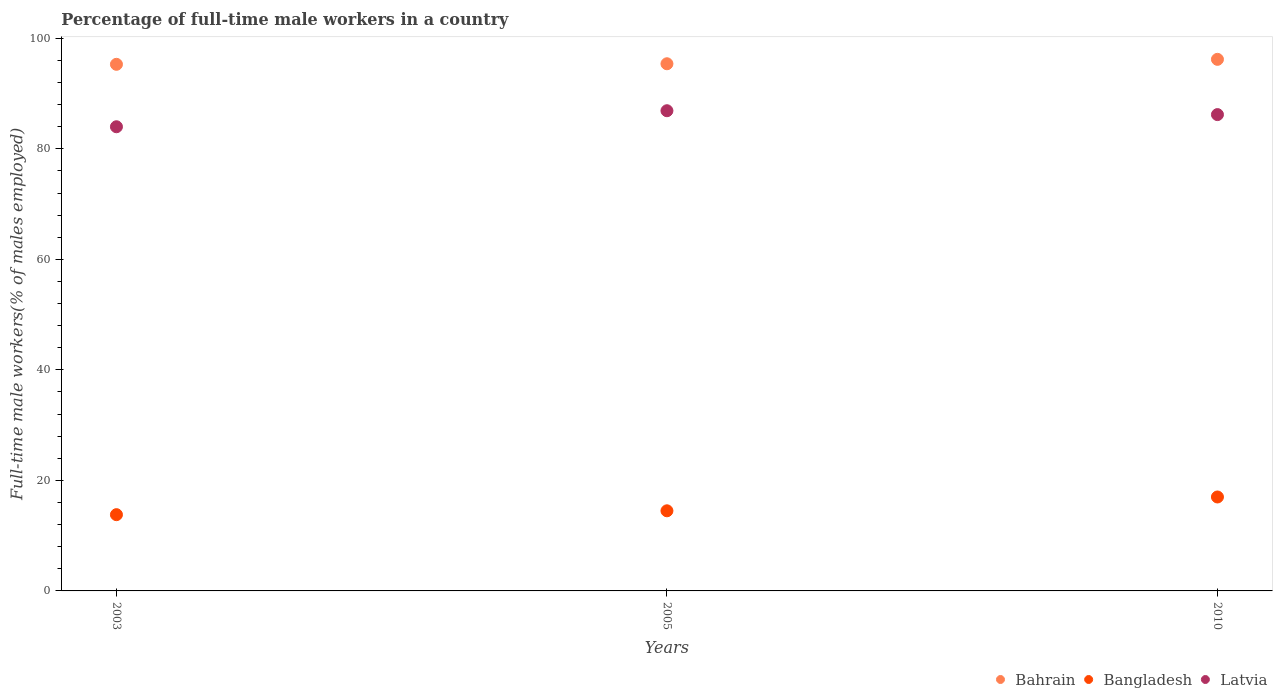Is the number of dotlines equal to the number of legend labels?
Offer a terse response. Yes. What is the percentage of full-time male workers in Latvia in 2010?
Provide a short and direct response. 86.2. Across all years, what is the maximum percentage of full-time male workers in Bangladesh?
Ensure brevity in your answer.  17. Across all years, what is the minimum percentage of full-time male workers in Latvia?
Make the answer very short. 84. In which year was the percentage of full-time male workers in Bahrain maximum?
Provide a succinct answer. 2010. In which year was the percentage of full-time male workers in Bangladesh minimum?
Give a very brief answer. 2003. What is the total percentage of full-time male workers in Bangladesh in the graph?
Provide a succinct answer. 45.3. What is the difference between the percentage of full-time male workers in Bahrain in 2003 and that in 2005?
Provide a succinct answer. -0.1. What is the difference between the percentage of full-time male workers in Bahrain in 2005 and the percentage of full-time male workers in Bangladesh in 2010?
Your answer should be compact. 78.4. What is the average percentage of full-time male workers in Latvia per year?
Give a very brief answer. 85.7. In the year 2003, what is the difference between the percentage of full-time male workers in Bahrain and percentage of full-time male workers in Bangladesh?
Give a very brief answer. 81.5. What is the ratio of the percentage of full-time male workers in Bangladesh in 2003 to that in 2010?
Offer a very short reply. 0.81. Is the difference between the percentage of full-time male workers in Bahrain in 2003 and 2010 greater than the difference between the percentage of full-time male workers in Bangladesh in 2003 and 2010?
Give a very brief answer. Yes. What is the difference between the highest and the second highest percentage of full-time male workers in Latvia?
Your answer should be compact. 0.7. What is the difference between the highest and the lowest percentage of full-time male workers in Latvia?
Provide a succinct answer. 2.9. Is it the case that in every year, the sum of the percentage of full-time male workers in Bahrain and percentage of full-time male workers in Latvia  is greater than the percentage of full-time male workers in Bangladesh?
Make the answer very short. Yes. Does the percentage of full-time male workers in Bangladesh monotonically increase over the years?
Offer a terse response. Yes. How many dotlines are there?
Offer a terse response. 3. How many years are there in the graph?
Ensure brevity in your answer.  3. What is the title of the graph?
Give a very brief answer. Percentage of full-time male workers in a country. Does "Cayman Islands" appear as one of the legend labels in the graph?
Your response must be concise. No. What is the label or title of the Y-axis?
Your answer should be compact. Full-time male workers(% of males employed). What is the Full-time male workers(% of males employed) in Bahrain in 2003?
Make the answer very short. 95.3. What is the Full-time male workers(% of males employed) of Bangladesh in 2003?
Keep it short and to the point. 13.8. What is the Full-time male workers(% of males employed) in Bahrain in 2005?
Your answer should be compact. 95.4. What is the Full-time male workers(% of males employed) of Latvia in 2005?
Provide a succinct answer. 86.9. What is the Full-time male workers(% of males employed) in Bahrain in 2010?
Keep it short and to the point. 96.2. What is the Full-time male workers(% of males employed) of Latvia in 2010?
Your answer should be very brief. 86.2. Across all years, what is the maximum Full-time male workers(% of males employed) in Bahrain?
Make the answer very short. 96.2. Across all years, what is the maximum Full-time male workers(% of males employed) of Bangladesh?
Your answer should be very brief. 17. Across all years, what is the maximum Full-time male workers(% of males employed) of Latvia?
Your response must be concise. 86.9. Across all years, what is the minimum Full-time male workers(% of males employed) of Bahrain?
Offer a terse response. 95.3. Across all years, what is the minimum Full-time male workers(% of males employed) in Bangladesh?
Make the answer very short. 13.8. Across all years, what is the minimum Full-time male workers(% of males employed) of Latvia?
Provide a succinct answer. 84. What is the total Full-time male workers(% of males employed) of Bahrain in the graph?
Ensure brevity in your answer.  286.9. What is the total Full-time male workers(% of males employed) of Bangladesh in the graph?
Keep it short and to the point. 45.3. What is the total Full-time male workers(% of males employed) in Latvia in the graph?
Your response must be concise. 257.1. What is the difference between the Full-time male workers(% of males employed) in Bangladesh in 2003 and that in 2005?
Provide a succinct answer. -0.7. What is the difference between the Full-time male workers(% of males employed) in Bangladesh in 2003 and that in 2010?
Make the answer very short. -3.2. What is the difference between the Full-time male workers(% of males employed) of Latvia in 2003 and that in 2010?
Your response must be concise. -2.2. What is the difference between the Full-time male workers(% of males employed) of Latvia in 2005 and that in 2010?
Ensure brevity in your answer.  0.7. What is the difference between the Full-time male workers(% of males employed) in Bahrain in 2003 and the Full-time male workers(% of males employed) in Bangladesh in 2005?
Keep it short and to the point. 80.8. What is the difference between the Full-time male workers(% of males employed) of Bangladesh in 2003 and the Full-time male workers(% of males employed) of Latvia in 2005?
Provide a succinct answer. -73.1. What is the difference between the Full-time male workers(% of males employed) of Bahrain in 2003 and the Full-time male workers(% of males employed) of Bangladesh in 2010?
Give a very brief answer. 78.3. What is the difference between the Full-time male workers(% of males employed) of Bahrain in 2003 and the Full-time male workers(% of males employed) of Latvia in 2010?
Ensure brevity in your answer.  9.1. What is the difference between the Full-time male workers(% of males employed) in Bangladesh in 2003 and the Full-time male workers(% of males employed) in Latvia in 2010?
Offer a terse response. -72.4. What is the difference between the Full-time male workers(% of males employed) of Bahrain in 2005 and the Full-time male workers(% of males employed) of Bangladesh in 2010?
Ensure brevity in your answer.  78.4. What is the difference between the Full-time male workers(% of males employed) in Bangladesh in 2005 and the Full-time male workers(% of males employed) in Latvia in 2010?
Make the answer very short. -71.7. What is the average Full-time male workers(% of males employed) in Bahrain per year?
Provide a short and direct response. 95.63. What is the average Full-time male workers(% of males employed) in Latvia per year?
Make the answer very short. 85.7. In the year 2003, what is the difference between the Full-time male workers(% of males employed) in Bahrain and Full-time male workers(% of males employed) in Bangladesh?
Provide a short and direct response. 81.5. In the year 2003, what is the difference between the Full-time male workers(% of males employed) in Bahrain and Full-time male workers(% of males employed) in Latvia?
Offer a terse response. 11.3. In the year 2003, what is the difference between the Full-time male workers(% of males employed) in Bangladesh and Full-time male workers(% of males employed) in Latvia?
Give a very brief answer. -70.2. In the year 2005, what is the difference between the Full-time male workers(% of males employed) of Bahrain and Full-time male workers(% of males employed) of Bangladesh?
Your answer should be very brief. 80.9. In the year 2005, what is the difference between the Full-time male workers(% of males employed) of Bahrain and Full-time male workers(% of males employed) of Latvia?
Give a very brief answer. 8.5. In the year 2005, what is the difference between the Full-time male workers(% of males employed) of Bangladesh and Full-time male workers(% of males employed) of Latvia?
Make the answer very short. -72.4. In the year 2010, what is the difference between the Full-time male workers(% of males employed) in Bahrain and Full-time male workers(% of males employed) in Bangladesh?
Your response must be concise. 79.2. In the year 2010, what is the difference between the Full-time male workers(% of males employed) in Bahrain and Full-time male workers(% of males employed) in Latvia?
Your answer should be very brief. 10. In the year 2010, what is the difference between the Full-time male workers(% of males employed) of Bangladesh and Full-time male workers(% of males employed) of Latvia?
Keep it short and to the point. -69.2. What is the ratio of the Full-time male workers(% of males employed) in Bangladesh in 2003 to that in 2005?
Provide a short and direct response. 0.95. What is the ratio of the Full-time male workers(% of males employed) of Latvia in 2003 to that in 2005?
Keep it short and to the point. 0.97. What is the ratio of the Full-time male workers(% of males employed) in Bahrain in 2003 to that in 2010?
Your answer should be compact. 0.99. What is the ratio of the Full-time male workers(% of males employed) of Bangladesh in 2003 to that in 2010?
Provide a succinct answer. 0.81. What is the ratio of the Full-time male workers(% of males employed) of Latvia in 2003 to that in 2010?
Your answer should be very brief. 0.97. What is the ratio of the Full-time male workers(% of males employed) in Bahrain in 2005 to that in 2010?
Keep it short and to the point. 0.99. What is the ratio of the Full-time male workers(% of males employed) of Bangladesh in 2005 to that in 2010?
Make the answer very short. 0.85. What is the ratio of the Full-time male workers(% of males employed) of Latvia in 2005 to that in 2010?
Provide a short and direct response. 1.01. What is the difference between the highest and the second highest Full-time male workers(% of males employed) in Bangladesh?
Your answer should be compact. 2.5. What is the difference between the highest and the lowest Full-time male workers(% of males employed) in Bahrain?
Ensure brevity in your answer.  0.9. What is the difference between the highest and the lowest Full-time male workers(% of males employed) of Bangladesh?
Your response must be concise. 3.2. What is the difference between the highest and the lowest Full-time male workers(% of males employed) in Latvia?
Provide a succinct answer. 2.9. 